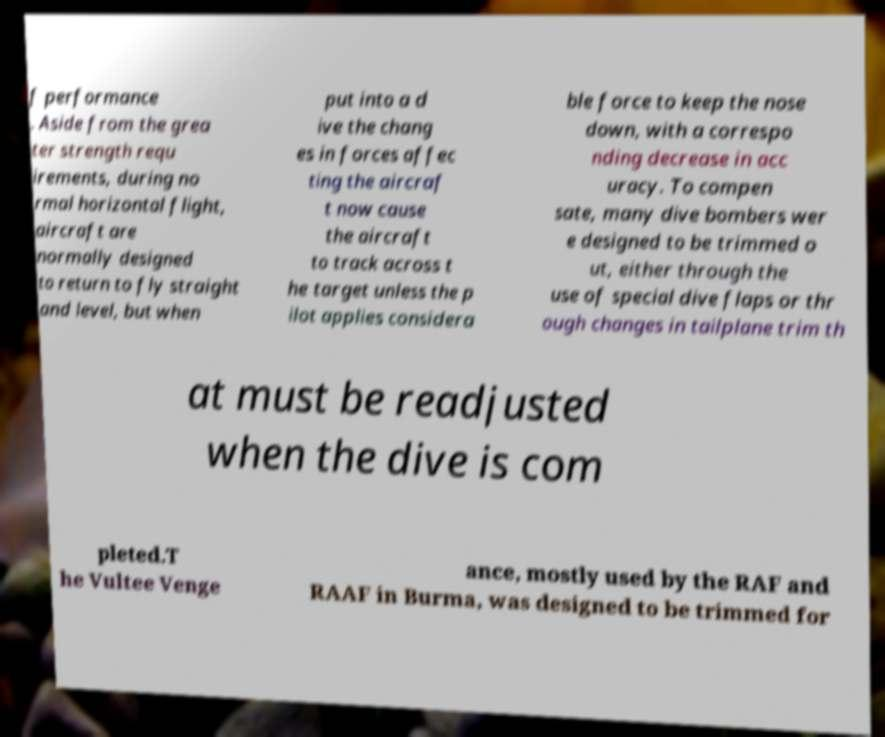Please read and relay the text visible in this image. What does it say? f performance . Aside from the grea ter strength requ irements, during no rmal horizontal flight, aircraft are normally designed to return to fly straight and level, but when put into a d ive the chang es in forces affec ting the aircraf t now cause the aircraft to track across t he target unless the p ilot applies considera ble force to keep the nose down, with a correspo nding decrease in acc uracy. To compen sate, many dive bombers wer e designed to be trimmed o ut, either through the use of special dive flaps or thr ough changes in tailplane trim th at must be readjusted when the dive is com pleted.T he Vultee Venge ance, mostly used by the RAF and RAAF in Burma, was designed to be trimmed for 